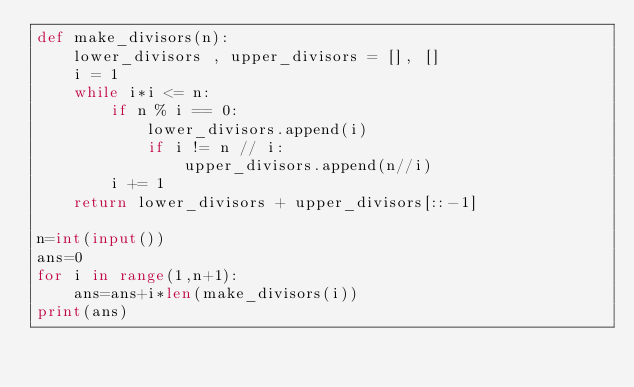<code> <loc_0><loc_0><loc_500><loc_500><_Python_>def make_divisors(n):
    lower_divisors , upper_divisors = [], []
    i = 1
    while i*i <= n:
        if n % i == 0:
            lower_divisors.append(i)
            if i != n // i:
                upper_divisors.append(n//i)
        i += 1
    return lower_divisors + upper_divisors[::-1]

n=int(input())
ans=0
for i in range(1,n+1):
    ans=ans+i*len(make_divisors(i))
print(ans)</code> 